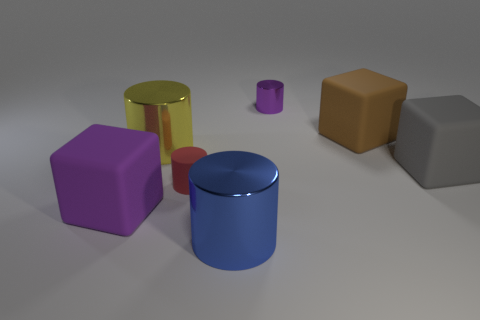The other cylinder that is the same size as the yellow metal cylinder is what color?
Offer a very short reply. Blue. Is the number of red cylinders that are left of the brown rubber object the same as the number of gray rubber objects that are behind the big blue metallic object?
Offer a terse response. Yes. The big cylinder on the right side of the shiny object that is left of the matte cylinder is made of what material?
Offer a very short reply. Metal. What number of things are either small matte objects or big cyan cylinders?
Provide a succinct answer. 1. What size is the thing that is the same color as the tiny shiny cylinder?
Provide a short and direct response. Large. Is the number of small cyan metal cylinders less than the number of purple cylinders?
Offer a terse response. Yes. What size is the red thing that is made of the same material as the large purple block?
Make the answer very short. Small. The red matte cylinder has what size?
Your answer should be compact. Small. The big purple object is what shape?
Your response must be concise. Cube. Does the block that is on the left side of the big blue thing have the same color as the small metallic cylinder?
Provide a succinct answer. Yes. 